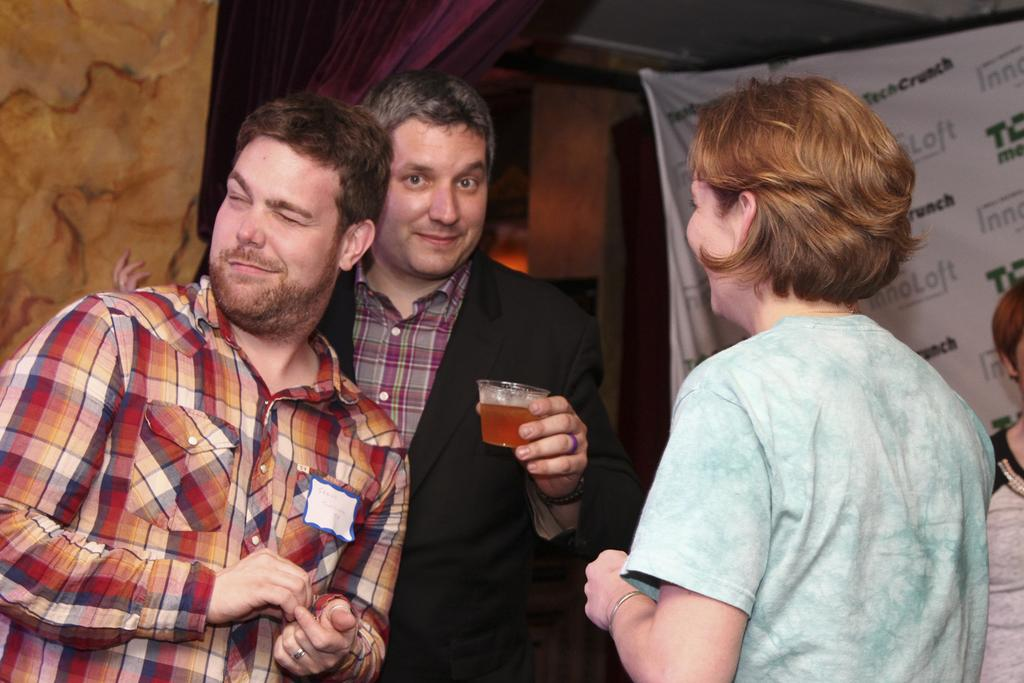How many people are in the image? There is a group of persons standing in the image. What is one person holding in the image? One person is holding a glass with a drink in it. What can be seen in the background of the image? In the background, there are cloth and curtains visible. What type of wave can be seen crashing on the shore in the image? There is no wave or shore present in the image; it features a group of persons standing with a person holding a glass with a drink, and cloth and curtains visible in the background. What scent is emanating from the person's leg in the image? There is no mention of a scent or a person's leg in the image. 